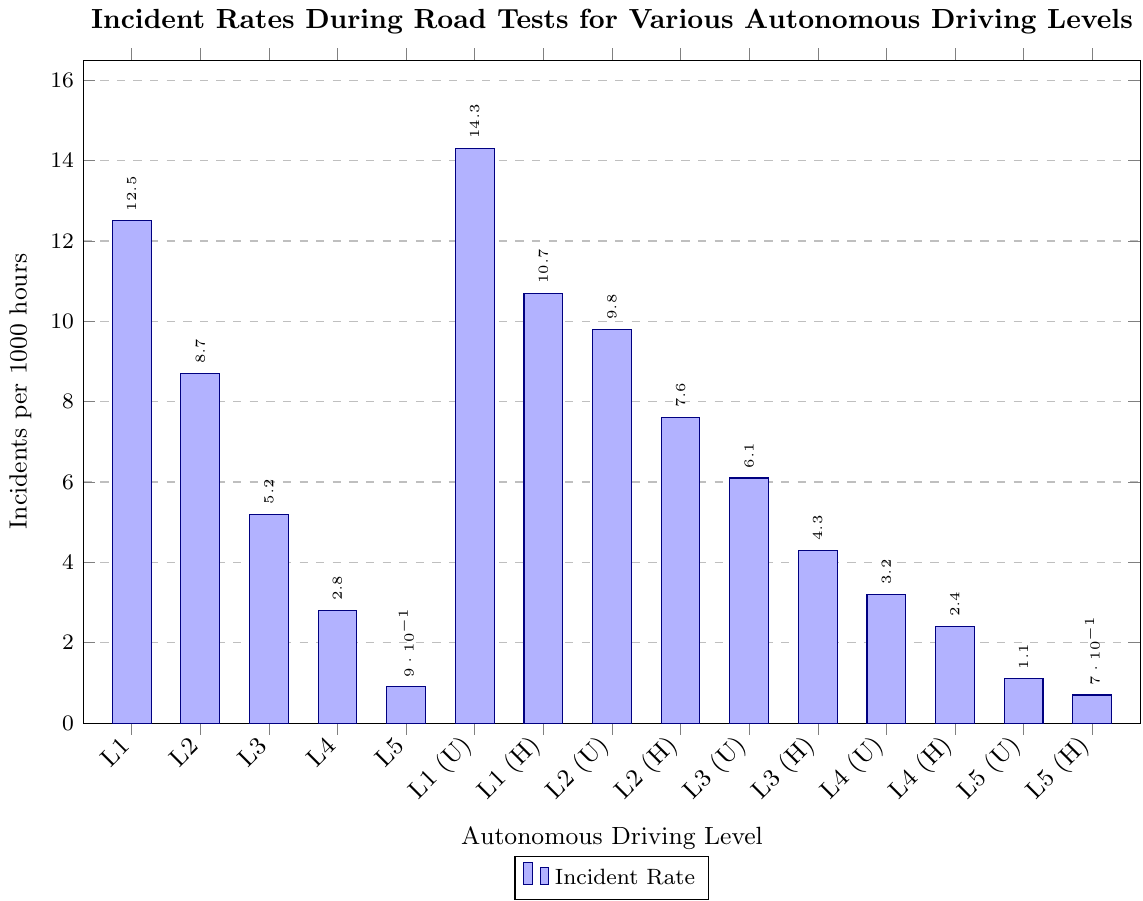What's the incident rate for L3 in urban settings? Identify the bar labeled L3 (Urban) and check the value. It is labeled as 6.1 incidents per 1000 hours.
Answer: 6.1 Which autonomous driving level has the lowest incident rate, and what is that rate? Observe the heights of all bars to determine which is the lowest. The bar for L5 (Highway) is the shortest, indicating the lowest incident rate of 0.7 incidents per 1000 hours.
Answer: L5 (Highway), 0.7 How does the incident rate for L1 on highways compare to L2 in urban areas? Locate the bars for L1 (Highway) and L2 (Urban). The heights of these bars correspond to 10.7 and 9.8 incidents per 1000 hours, respectively, indicating L1 (Highway) has a higher rate.
Answer: L1 (Highway) is higher What is the average incident rate for all the L4 scenarios? Add the incident rates for L4 (2.8), L4 (Urban) (3.2), and L4 (Highway) (2.4), then divide by 3. The sum is 8.4, and the average is 8.4 / 3 = 2.8.
Answer: 2.8 Which driving level shows the largest difference in incident rates between urban and highway settings, and what is this difference? Examine the differences between urban and highway rates for each level: L1 (14.3 - 10.7 = 3.6), L2 (9.8 - 7.6 = 2.2), L3 (6.1 - 4.3 = 1.8), L4 (3.2 - 2.4 = 0.8), and L5 (1.1 - 0.7 = 0.4). L1 has the largest difference of 3.6.
Answer: L1, 3.6 What's the combined total number of incidents for L3 (Urban) and L3 (Highway)? Add the incident rates for L3 in urban and highway settings: 6.1 + 4.3 = 10.4 incidents per 1000 hours.
Answer: 10.4 Rank the autonomous driving levels (L1 to L5 only) based on incidents rates from highest to lowest. The incidents per 1000 hours for each level are: L1 (12.5), L2 (8.7), L3 (5.2), L4 (2.8), and L5 (0.9). Ranking these from highest to lowest gives: L1, L2, L3, L4, L5.
Answer: L1, L2, L3, L4, L5 Compare the incident rates of L2 (Urban) to the average incident rate of L3 in all contexts. The incident rate for L2 (Urban) is 9.8. For L3, calculate the average of all contexts: (5.2 + 6.1 + 4.3) / 3 = 5.2. L2 (Urban) has a higher rate.
Answer: L2 (Urban) is higher Determine the combined incident rate for levels L1, L2, and L3 on highways. Add the incident rates for L1 (Highway) (10.7), L2 (Highway) (7.6), and L3 (Highway) (4.3): 10.7 + 7.6 + 4.3 = 22.6 incidents per 1000 hours.
Answer: 22.6 What is the difference in incident rate between L3 (Urban) and L4 (Urban)? Subtract the incident rate of L4 (Urban) from L3 (Urban): 6.1 - 3.2 = 2.9 incidents per 1000 hours.
Answer: 2.9 